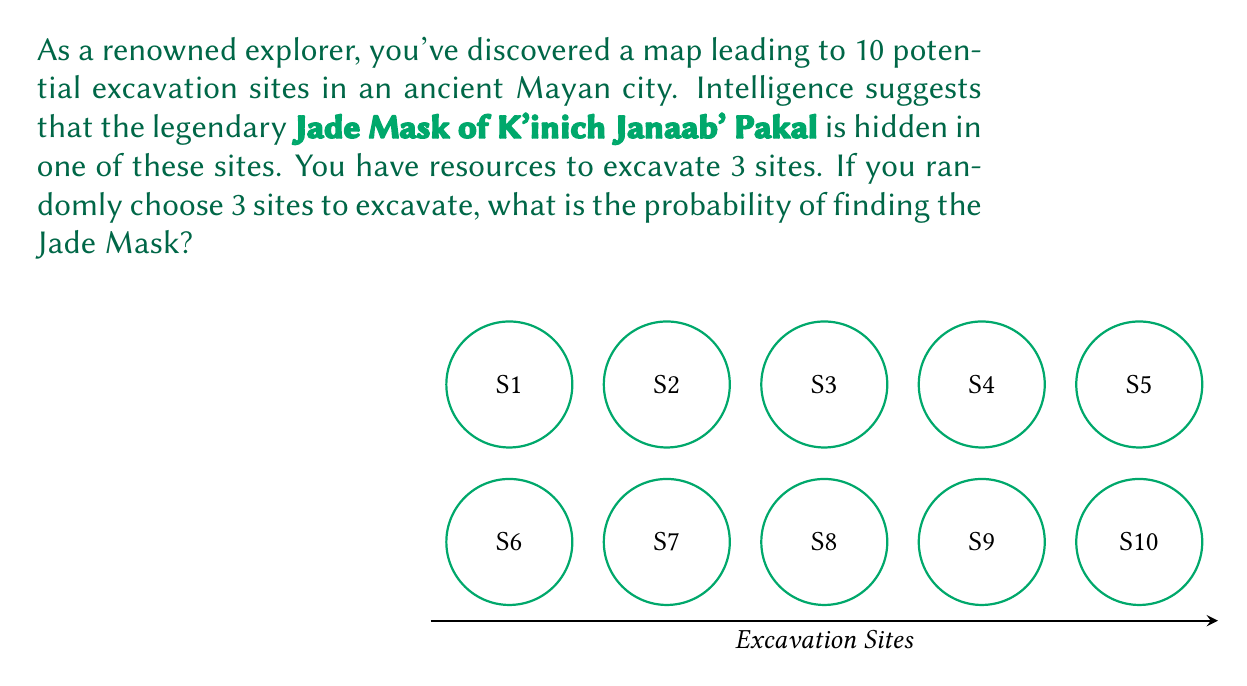Could you help me with this problem? Let's approach this step-by-step:

1) We can think of this as a combination problem. We need to calculate the probability of selecting the site with the Jade Mask when choosing 3 sites out of 10.

2) There are $\binom{10}{3}$ ways to choose 3 sites out of 10. This is our total number of possible outcomes.

3) The number of favorable outcomes is the number of ways to choose the site with the Jade Mask (1 way) and then any 2 of the remaining 9 sites. This is $1 \cdot \binom{9}{2}$.

4) The probability is then:

   $$P(\text{finding the Jade Mask}) = \frac{\text{favorable outcomes}}{\text{total outcomes}} = \frac{1 \cdot \binom{9}{2}}{\binom{10}{3}}$$

5) Let's calculate these values:
   
   $$\binom{10}{3} = \frac{10!}{3!(10-3)!} = \frac{10!}{3!7!} = 120$$
   
   $$\binom{9}{2} = \frac{9!}{2!(9-2)!} = \frac{9!}{2!7!} = 36$$

6) Substituting these values:

   $$P(\text{finding the Jade Mask}) = \frac{1 \cdot 36}{120} = \frac{3}{10} = 0.3$$

Therefore, the probability of finding the Jade Mask is 0.3 or 30%.
Answer: $\frac{3}{10}$ or 0.3 or 30% 